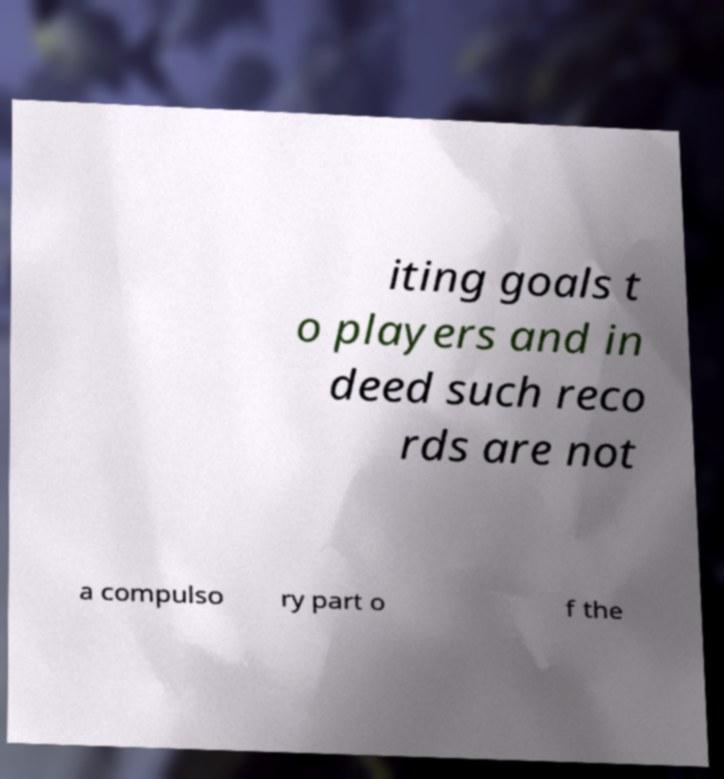Can you accurately transcribe the text from the provided image for me? iting goals t o players and in deed such reco rds are not a compulso ry part o f the 